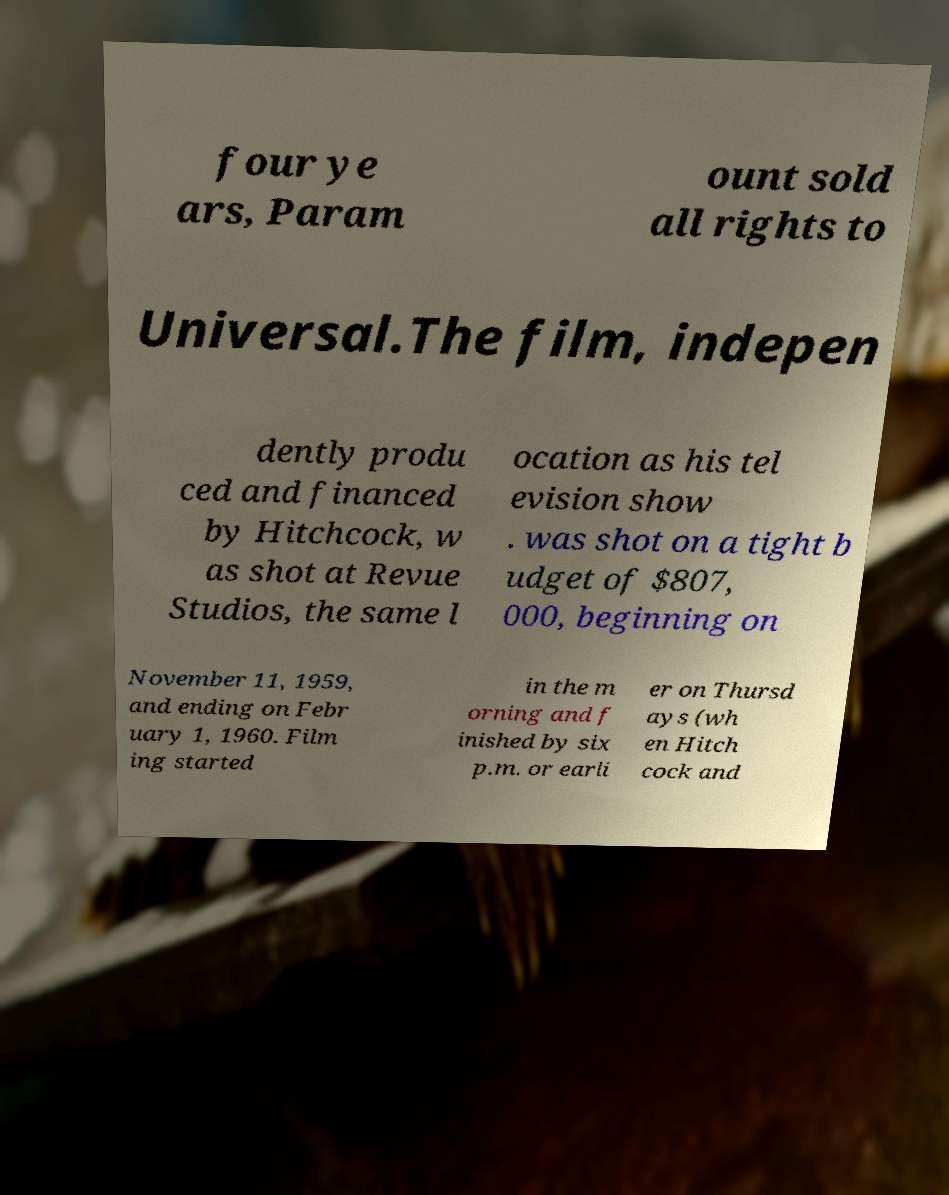There's text embedded in this image that I need extracted. Can you transcribe it verbatim? four ye ars, Param ount sold all rights to Universal.The film, indepen dently produ ced and financed by Hitchcock, w as shot at Revue Studios, the same l ocation as his tel evision show . was shot on a tight b udget of $807, 000, beginning on November 11, 1959, and ending on Febr uary 1, 1960. Film ing started in the m orning and f inished by six p.m. or earli er on Thursd ays (wh en Hitch cock and 